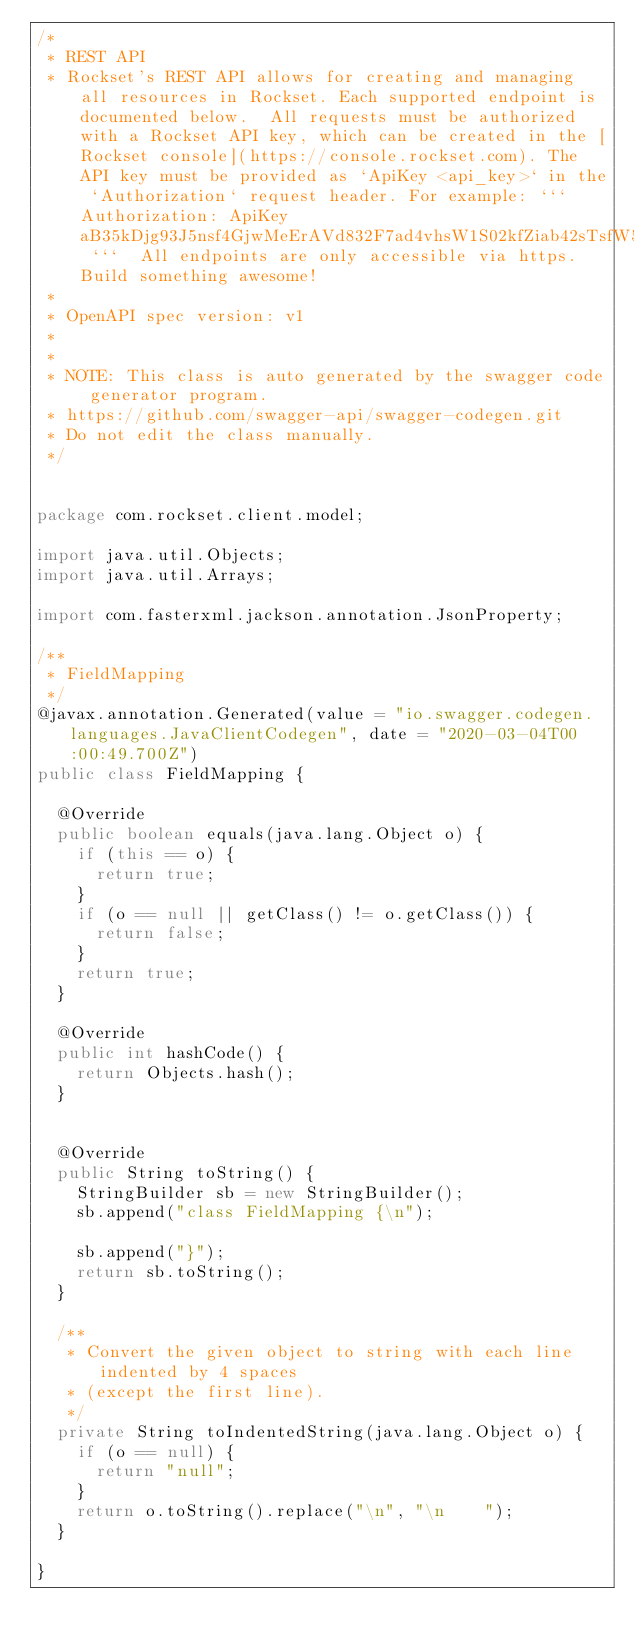<code> <loc_0><loc_0><loc_500><loc_500><_Java_>/*
 * REST API
 * Rockset's REST API allows for creating and managing all resources in Rockset. Each supported endpoint is documented below.  All requests must be authorized with a Rockset API key, which can be created in the [Rockset console](https://console.rockset.com). The API key must be provided as `ApiKey <api_key>` in the `Authorization` request header. For example: ``` Authorization: ApiKey aB35kDjg93J5nsf4GjwMeErAVd832F7ad4vhsW1S02kfZiab42sTsfW5Sxt25asT ```  All endpoints are only accessible via https.  Build something awesome!
 *
 * OpenAPI spec version: v1
 * 
 *
 * NOTE: This class is auto generated by the swagger code generator program.
 * https://github.com/swagger-api/swagger-codegen.git
 * Do not edit the class manually.
 */


package com.rockset.client.model;

import java.util.Objects;
import java.util.Arrays;

import com.fasterxml.jackson.annotation.JsonProperty;

/**
 * FieldMapping
 */
@javax.annotation.Generated(value = "io.swagger.codegen.languages.JavaClientCodegen", date = "2020-03-04T00:00:49.700Z")
public class FieldMapping {

  @Override
  public boolean equals(java.lang.Object o) {
    if (this == o) {
      return true;
    }
    if (o == null || getClass() != o.getClass()) {
      return false;
    }
    return true;
  }

  @Override
  public int hashCode() {
    return Objects.hash();
  }


  @Override
  public String toString() {
    StringBuilder sb = new StringBuilder();
    sb.append("class FieldMapping {\n");
    
    sb.append("}");
    return sb.toString();
  }

  /**
   * Convert the given object to string with each line indented by 4 spaces
   * (except the first line).
   */
  private String toIndentedString(java.lang.Object o) {
    if (o == null) {
      return "null";
    }
    return o.toString().replace("\n", "\n    ");
  }

}

</code> 